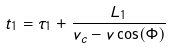<formula> <loc_0><loc_0><loc_500><loc_500>t _ { 1 } = \tau _ { 1 } + \frac { L _ { 1 } } { v _ { c } - v \cos ( \Phi ) }</formula> 